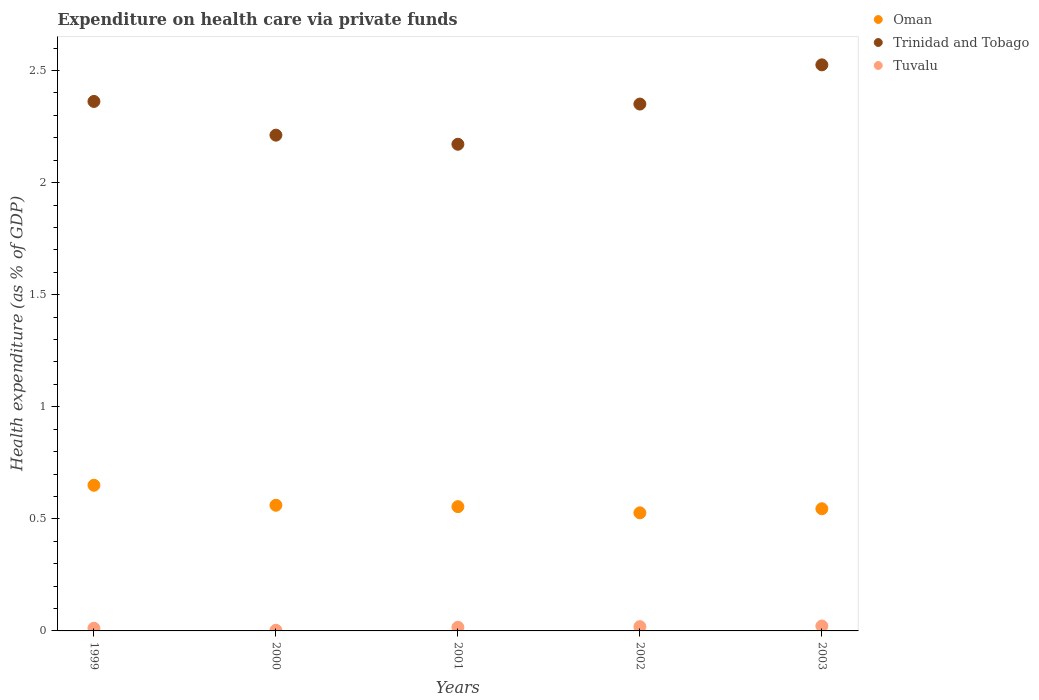Is the number of dotlines equal to the number of legend labels?
Your answer should be very brief. Yes. What is the expenditure made on health care in Tuvalu in 2003?
Your answer should be compact. 0.02. Across all years, what is the maximum expenditure made on health care in Trinidad and Tobago?
Ensure brevity in your answer.  2.53. Across all years, what is the minimum expenditure made on health care in Oman?
Your response must be concise. 0.53. In which year was the expenditure made on health care in Tuvalu maximum?
Offer a terse response. 2003. What is the total expenditure made on health care in Trinidad and Tobago in the graph?
Your answer should be compact. 11.62. What is the difference between the expenditure made on health care in Oman in 2000 and that in 2002?
Offer a very short reply. 0.03. What is the difference between the expenditure made on health care in Oman in 1999 and the expenditure made on health care in Tuvalu in 2000?
Provide a short and direct response. 0.65. What is the average expenditure made on health care in Tuvalu per year?
Offer a very short reply. 0.01. In the year 2003, what is the difference between the expenditure made on health care in Tuvalu and expenditure made on health care in Trinidad and Tobago?
Provide a succinct answer. -2.5. In how many years, is the expenditure made on health care in Trinidad and Tobago greater than 1.9 %?
Ensure brevity in your answer.  5. What is the ratio of the expenditure made on health care in Trinidad and Tobago in 2002 to that in 2003?
Give a very brief answer. 0.93. Is the expenditure made on health care in Tuvalu in 2000 less than that in 2002?
Your answer should be compact. Yes. Is the difference between the expenditure made on health care in Tuvalu in 2001 and 2002 greater than the difference between the expenditure made on health care in Trinidad and Tobago in 2001 and 2002?
Keep it short and to the point. Yes. What is the difference between the highest and the second highest expenditure made on health care in Trinidad and Tobago?
Keep it short and to the point. 0.16. What is the difference between the highest and the lowest expenditure made on health care in Tuvalu?
Ensure brevity in your answer.  0.02. Is the sum of the expenditure made on health care in Tuvalu in 1999 and 2002 greater than the maximum expenditure made on health care in Trinidad and Tobago across all years?
Provide a short and direct response. No. Does the expenditure made on health care in Trinidad and Tobago monotonically increase over the years?
Your answer should be compact. No. Is the expenditure made on health care in Trinidad and Tobago strictly less than the expenditure made on health care in Tuvalu over the years?
Your answer should be compact. No. How many dotlines are there?
Provide a short and direct response. 3. What is the difference between two consecutive major ticks on the Y-axis?
Your answer should be very brief. 0.5. Where does the legend appear in the graph?
Your answer should be compact. Top right. What is the title of the graph?
Provide a short and direct response. Expenditure on health care via private funds. What is the label or title of the X-axis?
Give a very brief answer. Years. What is the label or title of the Y-axis?
Your answer should be compact. Health expenditure (as % of GDP). What is the Health expenditure (as % of GDP) in Oman in 1999?
Your response must be concise. 0.65. What is the Health expenditure (as % of GDP) of Trinidad and Tobago in 1999?
Keep it short and to the point. 2.36. What is the Health expenditure (as % of GDP) of Tuvalu in 1999?
Provide a succinct answer. 0.01. What is the Health expenditure (as % of GDP) of Oman in 2000?
Provide a succinct answer. 0.56. What is the Health expenditure (as % of GDP) in Trinidad and Tobago in 2000?
Provide a succinct answer. 2.21. What is the Health expenditure (as % of GDP) in Tuvalu in 2000?
Your response must be concise. 0. What is the Health expenditure (as % of GDP) in Oman in 2001?
Provide a short and direct response. 0.55. What is the Health expenditure (as % of GDP) in Trinidad and Tobago in 2001?
Your answer should be compact. 2.17. What is the Health expenditure (as % of GDP) in Tuvalu in 2001?
Provide a short and direct response. 0.02. What is the Health expenditure (as % of GDP) in Oman in 2002?
Provide a short and direct response. 0.53. What is the Health expenditure (as % of GDP) of Trinidad and Tobago in 2002?
Offer a terse response. 2.35. What is the Health expenditure (as % of GDP) in Tuvalu in 2002?
Your answer should be compact. 0.02. What is the Health expenditure (as % of GDP) of Oman in 2003?
Make the answer very short. 0.55. What is the Health expenditure (as % of GDP) of Trinidad and Tobago in 2003?
Offer a very short reply. 2.53. What is the Health expenditure (as % of GDP) in Tuvalu in 2003?
Offer a very short reply. 0.02. Across all years, what is the maximum Health expenditure (as % of GDP) of Oman?
Offer a terse response. 0.65. Across all years, what is the maximum Health expenditure (as % of GDP) in Trinidad and Tobago?
Your answer should be very brief. 2.53. Across all years, what is the maximum Health expenditure (as % of GDP) of Tuvalu?
Provide a succinct answer. 0.02. Across all years, what is the minimum Health expenditure (as % of GDP) in Oman?
Offer a terse response. 0.53. Across all years, what is the minimum Health expenditure (as % of GDP) in Trinidad and Tobago?
Provide a succinct answer. 2.17. Across all years, what is the minimum Health expenditure (as % of GDP) of Tuvalu?
Make the answer very short. 0. What is the total Health expenditure (as % of GDP) of Oman in the graph?
Ensure brevity in your answer.  2.84. What is the total Health expenditure (as % of GDP) of Trinidad and Tobago in the graph?
Keep it short and to the point. 11.62. What is the total Health expenditure (as % of GDP) in Tuvalu in the graph?
Your response must be concise. 0.07. What is the difference between the Health expenditure (as % of GDP) of Oman in 1999 and that in 2000?
Offer a very short reply. 0.09. What is the difference between the Health expenditure (as % of GDP) in Trinidad and Tobago in 1999 and that in 2000?
Give a very brief answer. 0.15. What is the difference between the Health expenditure (as % of GDP) of Tuvalu in 1999 and that in 2000?
Your answer should be compact. 0.01. What is the difference between the Health expenditure (as % of GDP) in Oman in 1999 and that in 2001?
Keep it short and to the point. 0.1. What is the difference between the Health expenditure (as % of GDP) of Trinidad and Tobago in 1999 and that in 2001?
Offer a terse response. 0.19. What is the difference between the Health expenditure (as % of GDP) of Tuvalu in 1999 and that in 2001?
Your response must be concise. -0. What is the difference between the Health expenditure (as % of GDP) of Oman in 1999 and that in 2002?
Offer a terse response. 0.12. What is the difference between the Health expenditure (as % of GDP) in Trinidad and Tobago in 1999 and that in 2002?
Keep it short and to the point. 0.01. What is the difference between the Health expenditure (as % of GDP) of Tuvalu in 1999 and that in 2002?
Your answer should be compact. -0.01. What is the difference between the Health expenditure (as % of GDP) of Oman in 1999 and that in 2003?
Provide a succinct answer. 0.1. What is the difference between the Health expenditure (as % of GDP) in Trinidad and Tobago in 1999 and that in 2003?
Provide a succinct answer. -0.16. What is the difference between the Health expenditure (as % of GDP) in Tuvalu in 1999 and that in 2003?
Your response must be concise. -0.01. What is the difference between the Health expenditure (as % of GDP) in Oman in 2000 and that in 2001?
Your response must be concise. 0.01. What is the difference between the Health expenditure (as % of GDP) of Trinidad and Tobago in 2000 and that in 2001?
Your answer should be very brief. 0.04. What is the difference between the Health expenditure (as % of GDP) in Tuvalu in 2000 and that in 2001?
Provide a succinct answer. -0.01. What is the difference between the Health expenditure (as % of GDP) in Oman in 2000 and that in 2002?
Offer a very short reply. 0.03. What is the difference between the Health expenditure (as % of GDP) of Trinidad and Tobago in 2000 and that in 2002?
Give a very brief answer. -0.14. What is the difference between the Health expenditure (as % of GDP) in Tuvalu in 2000 and that in 2002?
Give a very brief answer. -0.02. What is the difference between the Health expenditure (as % of GDP) in Oman in 2000 and that in 2003?
Your response must be concise. 0.02. What is the difference between the Health expenditure (as % of GDP) of Trinidad and Tobago in 2000 and that in 2003?
Your answer should be compact. -0.31. What is the difference between the Health expenditure (as % of GDP) of Tuvalu in 2000 and that in 2003?
Keep it short and to the point. -0.02. What is the difference between the Health expenditure (as % of GDP) of Oman in 2001 and that in 2002?
Offer a very short reply. 0.03. What is the difference between the Health expenditure (as % of GDP) in Trinidad and Tobago in 2001 and that in 2002?
Provide a short and direct response. -0.18. What is the difference between the Health expenditure (as % of GDP) of Tuvalu in 2001 and that in 2002?
Offer a very short reply. -0. What is the difference between the Health expenditure (as % of GDP) of Oman in 2001 and that in 2003?
Your answer should be very brief. 0.01. What is the difference between the Health expenditure (as % of GDP) in Trinidad and Tobago in 2001 and that in 2003?
Your response must be concise. -0.35. What is the difference between the Health expenditure (as % of GDP) in Tuvalu in 2001 and that in 2003?
Ensure brevity in your answer.  -0.01. What is the difference between the Health expenditure (as % of GDP) in Oman in 2002 and that in 2003?
Your response must be concise. -0.02. What is the difference between the Health expenditure (as % of GDP) of Trinidad and Tobago in 2002 and that in 2003?
Provide a succinct answer. -0.17. What is the difference between the Health expenditure (as % of GDP) in Tuvalu in 2002 and that in 2003?
Ensure brevity in your answer.  -0. What is the difference between the Health expenditure (as % of GDP) in Oman in 1999 and the Health expenditure (as % of GDP) in Trinidad and Tobago in 2000?
Your answer should be very brief. -1.56. What is the difference between the Health expenditure (as % of GDP) of Oman in 1999 and the Health expenditure (as % of GDP) of Tuvalu in 2000?
Ensure brevity in your answer.  0.65. What is the difference between the Health expenditure (as % of GDP) in Trinidad and Tobago in 1999 and the Health expenditure (as % of GDP) in Tuvalu in 2000?
Give a very brief answer. 2.36. What is the difference between the Health expenditure (as % of GDP) in Oman in 1999 and the Health expenditure (as % of GDP) in Trinidad and Tobago in 2001?
Your response must be concise. -1.52. What is the difference between the Health expenditure (as % of GDP) in Oman in 1999 and the Health expenditure (as % of GDP) in Tuvalu in 2001?
Make the answer very short. 0.63. What is the difference between the Health expenditure (as % of GDP) of Trinidad and Tobago in 1999 and the Health expenditure (as % of GDP) of Tuvalu in 2001?
Keep it short and to the point. 2.35. What is the difference between the Health expenditure (as % of GDP) in Oman in 1999 and the Health expenditure (as % of GDP) in Trinidad and Tobago in 2002?
Your response must be concise. -1.7. What is the difference between the Health expenditure (as % of GDP) of Oman in 1999 and the Health expenditure (as % of GDP) of Tuvalu in 2002?
Give a very brief answer. 0.63. What is the difference between the Health expenditure (as % of GDP) of Trinidad and Tobago in 1999 and the Health expenditure (as % of GDP) of Tuvalu in 2002?
Your response must be concise. 2.34. What is the difference between the Health expenditure (as % of GDP) in Oman in 1999 and the Health expenditure (as % of GDP) in Trinidad and Tobago in 2003?
Your answer should be compact. -1.88. What is the difference between the Health expenditure (as % of GDP) in Oman in 1999 and the Health expenditure (as % of GDP) in Tuvalu in 2003?
Provide a succinct answer. 0.63. What is the difference between the Health expenditure (as % of GDP) in Trinidad and Tobago in 1999 and the Health expenditure (as % of GDP) in Tuvalu in 2003?
Keep it short and to the point. 2.34. What is the difference between the Health expenditure (as % of GDP) in Oman in 2000 and the Health expenditure (as % of GDP) in Trinidad and Tobago in 2001?
Your answer should be very brief. -1.61. What is the difference between the Health expenditure (as % of GDP) of Oman in 2000 and the Health expenditure (as % of GDP) of Tuvalu in 2001?
Offer a very short reply. 0.54. What is the difference between the Health expenditure (as % of GDP) in Trinidad and Tobago in 2000 and the Health expenditure (as % of GDP) in Tuvalu in 2001?
Offer a very short reply. 2.2. What is the difference between the Health expenditure (as % of GDP) of Oman in 2000 and the Health expenditure (as % of GDP) of Trinidad and Tobago in 2002?
Your answer should be compact. -1.79. What is the difference between the Health expenditure (as % of GDP) in Oman in 2000 and the Health expenditure (as % of GDP) in Tuvalu in 2002?
Your answer should be very brief. 0.54. What is the difference between the Health expenditure (as % of GDP) of Trinidad and Tobago in 2000 and the Health expenditure (as % of GDP) of Tuvalu in 2002?
Offer a very short reply. 2.19. What is the difference between the Health expenditure (as % of GDP) in Oman in 2000 and the Health expenditure (as % of GDP) in Trinidad and Tobago in 2003?
Make the answer very short. -1.96. What is the difference between the Health expenditure (as % of GDP) of Oman in 2000 and the Health expenditure (as % of GDP) of Tuvalu in 2003?
Offer a terse response. 0.54. What is the difference between the Health expenditure (as % of GDP) of Trinidad and Tobago in 2000 and the Health expenditure (as % of GDP) of Tuvalu in 2003?
Provide a short and direct response. 2.19. What is the difference between the Health expenditure (as % of GDP) of Oman in 2001 and the Health expenditure (as % of GDP) of Trinidad and Tobago in 2002?
Offer a terse response. -1.8. What is the difference between the Health expenditure (as % of GDP) in Oman in 2001 and the Health expenditure (as % of GDP) in Tuvalu in 2002?
Keep it short and to the point. 0.54. What is the difference between the Health expenditure (as % of GDP) in Trinidad and Tobago in 2001 and the Health expenditure (as % of GDP) in Tuvalu in 2002?
Your answer should be very brief. 2.15. What is the difference between the Health expenditure (as % of GDP) of Oman in 2001 and the Health expenditure (as % of GDP) of Trinidad and Tobago in 2003?
Provide a succinct answer. -1.97. What is the difference between the Health expenditure (as % of GDP) in Oman in 2001 and the Health expenditure (as % of GDP) in Tuvalu in 2003?
Offer a terse response. 0.53. What is the difference between the Health expenditure (as % of GDP) of Trinidad and Tobago in 2001 and the Health expenditure (as % of GDP) of Tuvalu in 2003?
Make the answer very short. 2.15. What is the difference between the Health expenditure (as % of GDP) of Oman in 2002 and the Health expenditure (as % of GDP) of Trinidad and Tobago in 2003?
Keep it short and to the point. -2. What is the difference between the Health expenditure (as % of GDP) of Oman in 2002 and the Health expenditure (as % of GDP) of Tuvalu in 2003?
Keep it short and to the point. 0.51. What is the difference between the Health expenditure (as % of GDP) in Trinidad and Tobago in 2002 and the Health expenditure (as % of GDP) in Tuvalu in 2003?
Make the answer very short. 2.33. What is the average Health expenditure (as % of GDP) of Oman per year?
Offer a terse response. 0.57. What is the average Health expenditure (as % of GDP) in Trinidad and Tobago per year?
Your answer should be compact. 2.32. What is the average Health expenditure (as % of GDP) in Tuvalu per year?
Ensure brevity in your answer.  0.01. In the year 1999, what is the difference between the Health expenditure (as % of GDP) of Oman and Health expenditure (as % of GDP) of Trinidad and Tobago?
Your response must be concise. -1.71. In the year 1999, what is the difference between the Health expenditure (as % of GDP) of Oman and Health expenditure (as % of GDP) of Tuvalu?
Your answer should be compact. 0.64. In the year 1999, what is the difference between the Health expenditure (as % of GDP) in Trinidad and Tobago and Health expenditure (as % of GDP) in Tuvalu?
Your answer should be compact. 2.35. In the year 2000, what is the difference between the Health expenditure (as % of GDP) of Oman and Health expenditure (as % of GDP) of Trinidad and Tobago?
Keep it short and to the point. -1.65. In the year 2000, what is the difference between the Health expenditure (as % of GDP) of Oman and Health expenditure (as % of GDP) of Tuvalu?
Offer a terse response. 0.56. In the year 2000, what is the difference between the Health expenditure (as % of GDP) in Trinidad and Tobago and Health expenditure (as % of GDP) in Tuvalu?
Ensure brevity in your answer.  2.21. In the year 2001, what is the difference between the Health expenditure (as % of GDP) in Oman and Health expenditure (as % of GDP) in Trinidad and Tobago?
Offer a very short reply. -1.62. In the year 2001, what is the difference between the Health expenditure (as % of GDP) in Oman and Health expenditure (as % of GDP) in Tuvalu?
Your answer should be very brief. 0.54. In the year 2001, what is the difference between the Health expenditure (as % of GDP) in Trinidad and Tobago and Health expenditure (as % of GDP) in Tuvalu?
Give a very brief answer. 2.16. In the year 2002, what is the difference between the Health expenditure (as % of GDP) of Oman and Health expenditure (as % of GDP) of Trinidad and Tobago?
Your answer should be compact. -1.82. In the year 2002, what is the difference between the Health expenditure (as % of GDP) in Oman and Health expenditure (as % of GDP) in Tuvalu?
Provide a succinct answer. 0.51. In the year 2002, what is the difference between the Health expenditure (as % of GDP) of Trinidad and Tobago and Health expenditure (as % of GDP) of Tuvalu?
Make the answer very short. 2.33. In the year 2003, what is the difference between the Health expenditure (as % of GDP) in Oman and Health expenditure (as % of GDP) in Trinidad and Tobago?
Make the answer very short. -1.98. In the year 2003, what is the difference between the Health expenditure (as % of GDP) of Oman and Health expenditure (as % of GDP) of Tuvalu?
Make the answer very short. 0.52. In the year 2003, what is the difference between the Health expenditure (as % of GDP) in Trinidad and Tobago and Health expenditure (as % of GDP) in Tuvalu?
Offer a terse response. 2.5. What is the ratio of the Health expenditure (as % of GDP) of Oman in 1999 to that in 2000?
Your answer should be compact. 1.16. What is the ratio of the Health expenditure (as % of GDP) in Trinidad and Tobago in 1999 to that in 2000?
Your answer should be very brief. 1.07. What is the ratio of the Health expenditure (as % of GDP) of Tuvalu in 1999 to that in 2000?
Keep it short and to the point. 3.91. What is the ratio of the Health expenditure (as % of GDP) in Oman in 1999 to that in 2001?
Provide a short and direct response. 1.17. What is the ratio of the Health expenditure (as % of GDP) in Trinidad and Tobago in 1999 to that in 2001?
Provide a short and direct response. 1.09. What is the ratio of the Health expenditure (as % of GDP) in Tuvalu in 1999 to that in 2001?
Offer a very short reply. 0.74. What is the ratio of the Health expenditure (as % of GDP) of Oman in 1999 to that in 2002?
Your answer should be very brief. 1.23. What is the ratio of the Health expenditure (as % of GDP) in Trinidad and Tobago in 1999 to that in 2002?
Make the answer very short. 1. What is the ratio of the Health expenditure (as % of GDP) in Tuvalu in 1999 to that in 2002?
Provide a short and direct response. 0.62. What is the ratio of the Health expenditure (as % of GDP) of Oman in 1999 to that in 2003?
Provide a succinct answer. 1.19. What is the ratio of the Health expenditure (as % of GDP) in Trinidad and Tobago in 1999 to that in 2003?
Provide a succinct answer. 0.94. What is the ratio of the Health expenditure (as % of GDP) of Tuvalu in 1999 to that in 2003?
Offer a very short reply. 0.54. What is the ratio of the Health expenditure (as % of GDP) of Oman in 2000 to that in 2001?
Your response must be concise. 1.01. What is the ratio of the Health expenditure (as % of GDP) in Trinidad and Tobago in 2000 to that in 2001?
Keep it short and to the point. 1.02. What is the ratio of the Health expenditure (as % of GDP) in Tuvalu in 2000 to that in 2001?
Ensure brevity in your answer.  0.19. What is the ratio of the Health expenditure (as % of GDP) of Oman in 2000 to that in 2002?
Ensure brevity in your answer.  1.06. What is the ratio of the Health expenditure (as % of GDP) in Trinidad and Tobago in 2000 to that in 2002?
Keep it short and to the point. 0.94. What is the ratio of the Health expenditure (as % of GDP) in Tuvalu in 2000 to that in 2002?
Offer a very short reply. 0.16. What is the ratio of the Health expenditure (as % of GDP) in Oman in 2000 to that in 2003?
Offer a very short reply. 1.03. What is the ratio of the Health expenditure (as % of GDP) in Trinidad and Tobago in 2000 to that in 2003?
Give a very brief answer. 0.88. What is the ratio of the Health expenditure (as % of GDP) in Tuvalu in 2000 to that in 2003?
Keep it short and to the point. 0.14. What is the ratio of the Health expenditure (as % of GDP) in Oman in 2001 to that in 2002?
Give a very brief answer. 1.05. What is the ratio of the Health expenditure (as % of GDP) in Trinidad and Tobago in 2001 to that in 2002?
Your answer should be very brief. 0.92. What is the ratio of the Health expenditure (as % of GDP) of Tuvalu in 2001 to that in 2002?
Offer a terse response. 0.84. What is the ratio of the Health expenditure (as % of GDP) in Oman in 2001 to that in 2003?
Provide a succinct answer. 1.02. What is the ratio of the Health expenditure (as % of GDP) in Trinidad and Tobago in 2001 to that in 2003?
Offer a terse response. 0.86. What is the ratio of the Health expenditure (as % of GDP) of Tuvalu in 2001 to that in 2003?
Your answer should be compact. 0.74. What is the ratio of the Health expenditure (as % of GDP) in Oman in 2002 to that in 2003?
Keep it short and to the point. 0.97. What is the ratio of the Health expenditure (as % of GDP) of Trinidad and Tobago in 2002 to that in 2003?
Your answer should be very brief. 0.93. What is the ratio of the Health expenditure (as % of GDP) in Tuvalu in 2002 to that in 2003?
Ensure brevity in your answer.  0.88. What is the difference between the highest and the second highest Health expenditure (as % of GDP) in Oman?
Your answer should be compact. 0.09. What is the difference between the highest and the second highest Health expenditure (as % of GDP) in Trinidad and Tobago?
Offer a terse response. 0.16. What is the difference between the highest and the second highest Health expenditure (as % of GDP) of Tuvalu?
Provide a succinct answer. 0. What is the difference between the highest and the lowest Health expenditure (as % of GDP) of Oman?
Your answer should be very brief. 0.12. What is the difference between the highest and the lowest Health expenditure (as % of GDP) in Trinidad and Tobago?
Offer a very short reply. 0.35. What is the difference between the highest and the lowest Health expenditure (as % of GDP) of Tuvalu?
Your response must be concise. 0.02. 